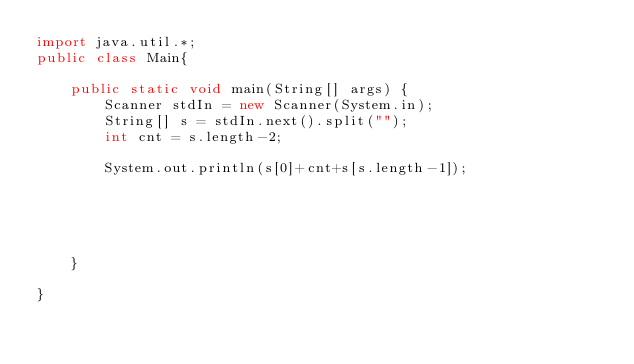Convert code to text. <code><loc_0><loc_0><loc_500><loc_500><_Java_>import java.util.*;
public class Main{

	public static void main(String[] args) {
		Scanner stdIn = new Scanner(System.in);
		String[] s = stdIn.next().split("");
		int cnt = s.length-2;
		
		System.out.println(s[0]+cnt+s[s.length-1]);
		
		
		
		
		
	}

}
</code> 